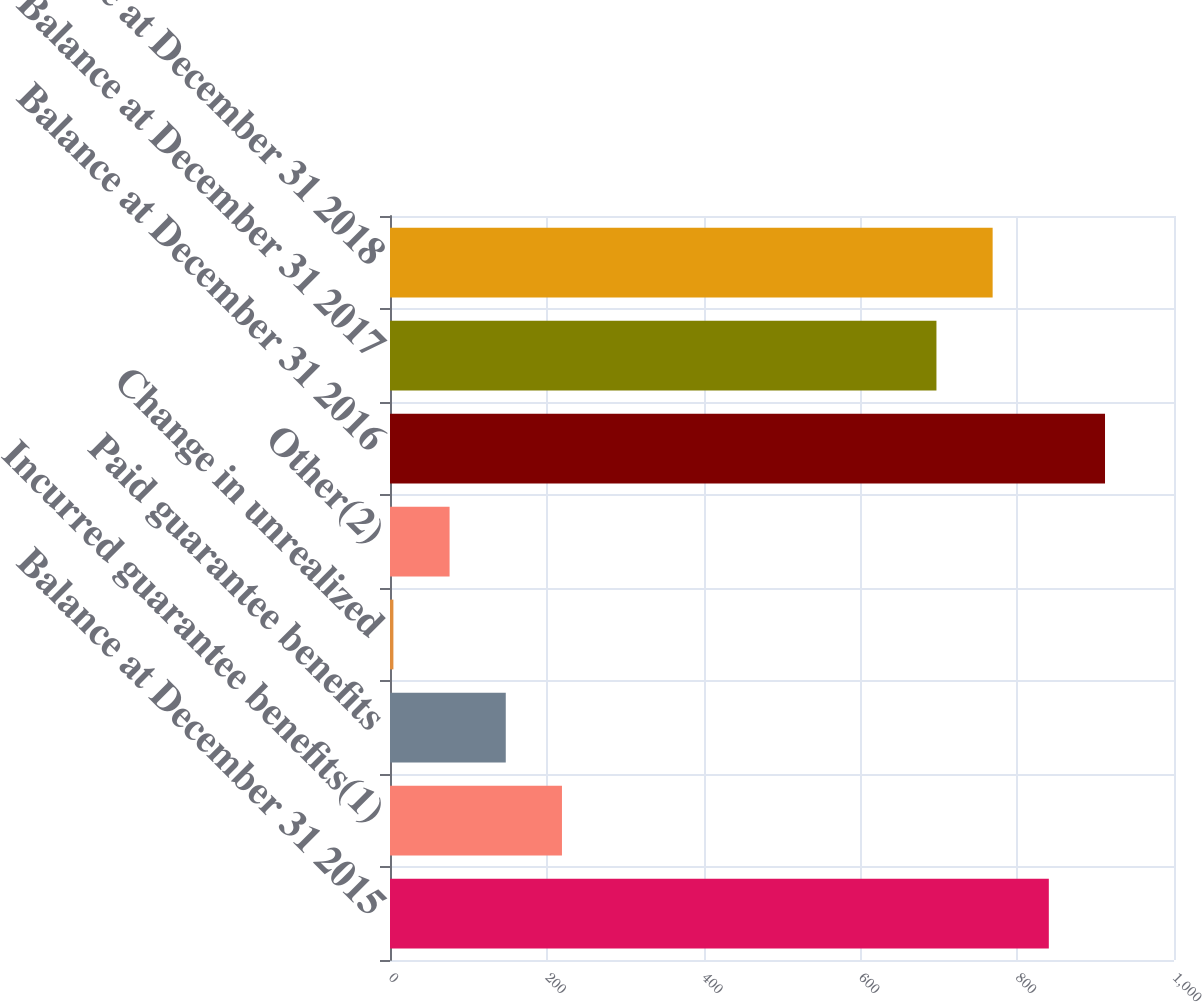Convert chart. <chart><loc_0><loc_0><loc_500><loc_500><bar_chart><fcel>Balance at December 31 2015<fcel>Incurred guarantee benefits(1)<fcel>Paid guarantee benefits<fcel>Change in unrealized<fcel>Other(2)<fcel>Balance at December 31 2016<fcel>Balance at December 31 2017<fcel>Balance at December 31 2018<nl><fcel>840.34<fcel>219.34<fcel>147.67<fcel>4.33<fcel>76<fcel>912.01<fcel>697<fcel>768.67<nl></chart> 